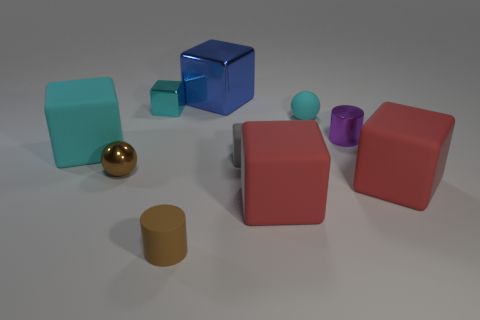Subtract all blue cylinders. How many cyan blocks are left? 2 Subtract all tiny shiny cubes. How many cubes are left? 5 Subtract all blue cubes. How many cubes are left? 5 Subtract all cubes. How many objects are left? 4 Subtract 1 cubes. How many cubes are left? 5 Subtract all cyan blocks. Subtract all cyan balls. How many blocks are left? 4 Subtract all blue matte cylinders. Subtract all big cyan blocks. How many objects are left? 9 Add 3 tiny purple objects. How many tiny purple objects are left? 4 Add 4 red balls. How many red balls exist? 4 Subtract 1 brown cylinders. How many objects are left? 9 